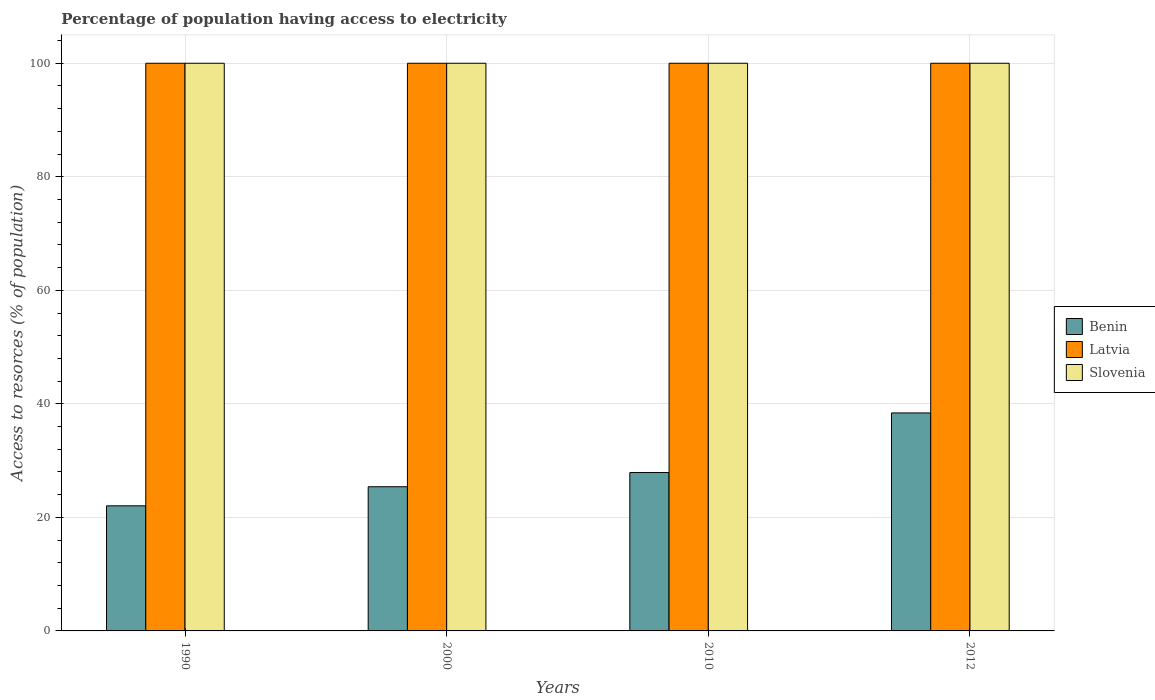Are the number of bars on each tick of the X-axis equal?
Provide a short and direct response. Yes. What is the percentage of population having access to electricity in Latvia in 1990?
Offer a terse response. 100. Across all years, what is the maximum percentage of population having access to electricity in Benin?
Your answer should be very brief. 38.4. Across all years, what is the minimum percentage of population having access to electricity in Slovenia?
Your answer should be compact. 100. In which year was the percentage of population having access to electricity in Latvia minimum?
Offer a terse response. 1990. What is the total percentage of population having access to electricity in Slovenia in the graph?
Give a very brief answer. 400. What is the difference between the percentage of population having access to electricity in Latvia in 2000 and that in 2012?
Provide a short and direct response. 0. What is the difference between the percentage of population having access to electricity in Slovenia in 2010 and the percentage of population having access to electricity in Benin in 1990?
Provide a succinct answer. 77.96. What is the average percentage of population having access to electricity in Benin per year?
Your answer should be very brief. 28.43. In the year 2012, what is the difference between the percentage of population having access to electricity in Latvia and percentage of population having access to electricity in Benin?
Give a very brief answer. 61.6. In how many years, is the percentage of population having access to electricity in Latvia greater than 28 %?
Your response must be concise. 4. What is the ratio of the percentage of population having access to electricity in Benin in 2010 to that in 2012?
Your response must be concise. 0.73. Is the difference between the percentage of population having access to electricity in Latvia in 2000 and 2012 greater than the difference between the percentage of population having access to electricity in Benin in 2000 and 2012?
Your answer should be compact. Yes. What is the difference between the highest and the second highest percentage of population having access to electricity in Benin?
Ensure brevity in your answer.  10.5. What is the difference between the highest and the lowest percentage of population having access to electricity in Benin?
Offer a very short reply. 16.36. What does the 3rd bar from the left in 2012 represents?
Make the answer very short. Slovenia. What does the 3rd bar from the right in 2012 represents?
Offer a terse response. Benin. Does the graph contain any zero values?
Provide a short and direct response. No. How many legend labels are there?
Make the answer very short. 3. How are the legend labels stacked?
Your answer should be very brief. Vertical. What is the title of the graph?
Offer a very short reply. Percentage of population having access to electricity. What is the label or title of the X-axis?
Ensure brevity in your answer.  Years. What is the label or title of the Y-axis?
Ensure brevity in your answer.  Access to resorces (% of population). What is the Access to resorces (% of population) in Benin in 1990?
Give a very brief answer. 22.04. What is the Access to resorces (% of population) of Latvia in 1990?
Give a very brief answer. 100. What is the Access to resorces (% of population) in Slovenia in 1990?
Your answer should be very brief. 100. What is the Access to resorces (% of population) in Benin in 2000?
Offer a very short reply. 25.4. What is the Access to resorces (% of population) in Benin in 2010?
Offer a very short reply. 27.9. What is the Access to resorces (% of population) in Slovenia in 2010?
Provide a succinct answer. 100. What is the Access to resorces (% of population) of Benin in 2012?
Provide a short and direct response. 38.4. What is the Access to resorces (% of population) of Slovenia in 2012?
Offer a terse response. 100. Across all years, what is the maximum Access to resorces (% of population) of Benin?
Offer a terse response. 38.4. Across all years, what is the maximum Access to resorces (% of population) of Latvia?
Offer a terse response. 100. Across all years, what is the maximum Access to resorces (% of population) of Slovenia?
Your response must be concise. 100. Across all years, what is the minimum Access to resorces (% of population) in Benin?
Ensure brevity in your answer.  22.04. Across all years, what is the minimum Access to resorces (% of population) of Latvia?
Ensure brevity in your answer.  100. What is the total Access to resorces (% of population) of Benin in the graph?
Provide a short and direct response. 113.74. What is the total Access to resorces (% of population) of Latvia in the graph?
Offer a very short reply. 400. What is the difference between the Access to resorces (% of population) of Benin in 1990 and that in 2000?
Keep it short and to the point. -3.36. What is the difference between the Access to resorces (% of population) of Latvia in 1990 and that in 2000?
Provide a succinct answer. 0. What is the difference between the Access to resorces (% of population) in Slovenia in 1990 and that in 2000?
Your response must be concise. 0. What is the difference between the Access to resorces (% of population) of Benin in 1990 and that in 2010?
Make the answer very short. -5.86. What is the difference between the Access to resorces (% of population) in Latvia in 1990 and that in 2010?
Keep it short and to the point. 0. What is the difference between the Access to resorces (% of population) in Benin in 1990 and that in 2012?
Your response must be concise. -16.36. What is the difference between the Access to resorces (% of population) in Slovenia in 1990 and that in 2012?
Offer a very short reply. 0. What is the difference between the Access to resorces (% of population) of Benin in 2000 and that in 2010?
Provide a succinct answer. -2.5. What is the difference between the Access to resorces (% of population) of Slovenia in 2000 and that in 2010?
Provide a short and direct response. 0. What is the difference between the Access to resorces (% of population) in Benin in 2000 and that in 2012?
Make the answer very short. -13. What is the difference between the Access to resorces (% of population) of Slovenia in 2000 and that in 2012?
Ensure brevity in your answer.  0. What is the difference between the Access to resorces (% of population) of Latvia in 2010 and that in 2012?
Make the answer very short. 0. What is the difference between the Access to resorces (% of population) of Slovenia in 2010 and that in 2012?
Your answer should be very brief. 0. What is the difference between the Access to resorces (% of population) in Benin in 1990 and the Access to resorces (% of population) in Latvia in 2000?
Your answer should be very brief. -77.96. What is the difference between the Access to resorces (% of population) in Benin in 1990 and the Access to resorces (% of population) in Slovenia in 2000?
Provide a succinct answer. -77.96. What is the difference between the Access to resorces (% of population) in Latvia in 1990 and the Access to resorces (% of population) in Slovenia in 2000?
Offer a terse response. 0. What is the difference between the Access to resorces (% of population) in Benin in 1990 and the Access to resorces (% of population) in Latvia in 2010?
Your answer should be compact. -77.96. What is the difference between the Access to resorces (% of population) of Benin in 1990 and the Access to resorces (% of population) of Slovenia in 2010?
Give a very brief answer. -77.96. What is the difference between the Access to resorces (% of population) of Latvia in 1990 and the Access to resorces (% of population) of Slovenia in 2010?
Provide a succinct answer. 0. What is the difference between the Access to resorces (% of population) in Benin in 1990 and the Access to resorces (% of population) in Latvia in 2012?
Your response must be concise. -77.96. What is the difference between the Access to resorces (% of population) of Benin in 1990 and the Access to resorces (% of population) of Slovenia in 2012?
Ensure brevity in your answer.  -77.96. What is the difference between the Access to resorces (% of population) in Latvia in 1990 and the Access to resorces (% of population) in Slovenia in 2012?
Give a very brief answer. 0. What is the difference between the Access to resorces (% of population) of Benin in 2000 and the Access to resorces (% of population) of Latvia in 2010?
Give a very brief answer. -74.6. What is the difference between the Access to resorces (% of population) of Benin in 2000 and the Access to resorces (% of population) of Slovenia in 2010?
Provide a succinct answer. -74.6. What is the difference between the Access to resorces (% of population) in Latvia in 2000 and the Access to resorces (% of population) in Slovenia in 2010?
Your response must be concise. 0. What is the difference between the Access to resorces (% of population) in Benin in 2000 and the Access to resorces (% of population) in Latvia in 2012?
Your answer should be compact. -74.6. What is the difference between the Access to resorces (% of population) in Benin in 2000 and the Access to resorces (% of population) in Slovenia in 2012?
Ensure brevity in your answer.  -74.6. What is the difference between the Access to resorces (% of population) in Latvia in 2000 and the Access to resorces (% of population) in Slovenia in 2012?
Provide a succinct answer. 0. What is the difference between the Access to resorces (% of population) of Benin in 2010 and the Access to resorces (% of population) of Latvia in 2012?
Your response must be concise. -72.1. What is the difference between the Access to resorces (% of population) in Benin in 2010 and the Access to resorces (% of population) in Slovenia in 2012?
Offer a very short reply. -72.1. What is the average Access to resorces (% of population) in Benin per year?
Keep it short and to the point. 28.43. In the year 1990, what is the difference between the Access to resorces (% of population) of Benin and Access to resorces (% of population) of Latvia?
Keep it short and to the point. -77.96. In the year 1990, what is the difference between the Access to resorces (% of population) in Benin and Access to resorces (% of population) in Slovenia?
Keep it short and to the point. -77.96. In the year 1990, what is the difference between the Access to resorces (% of population) in Latvia and Access to resorces (% of population) in Slovenia?
Make the answer very short. 0. In the year 2000, what is the difference between the Access to resorces (% of population) of Benin and Access to resorces (% of population) of Latvia?
Provide a short and direct response. -74.6. In the year 2000, what is the difference between the Access to resorces (% of population) in Benin and Access to resorces (% of population) in Slovenia?
Your response must be concise. -74.6. In the year 2010, what is the difference between the Access to resorces (% of population) of Benin and Access to resorces (% of population) of Latvia?
Provide a short and direct response. -72.1. In the year 2010, what is the difference between the Access to resorces (% of population) in Benin and Access to resorces (% of population) in Slovenia?
Your response must be concise. -72.1. In the year 2010, what is the difference between the Access to resorces (% of population) of Latvia and Access to resorces (% of population) of Slovenia?
Provide a short and direct response. 0. In the year 2012, what is the difference between the Access to resorces (% of population) in Benin and Access to resorces (% of population) in Latvia?
Ensure brevity in your answer.  -61.6. In the year 2012, what is the difference between the Access to resorces (% of population) of Benin and Access to resorces (% of population) of Slovenia?
Offer a terse response. -61.6. In the year 2012, what is the difference between the Access to resorces (% of population) of Latvia and Access to resorces (% of population) of Slovenia?
Your answer should be very brief. 0. What is the ratio of the Access to resorces (% of population) in Benin in 1990 to that in 2000?
Offer a terse response. 0.87. What is the ratio of the Access to resorces (% of population) of Benin in 1990 to that in 2010?
Your response must be concise. 0.79. What is the ratio of the Access to resorces (% of population) in Latvia in 1990 to that in 2010?
Offer a terse response. 1. What is the ratio of the Access to resorces (% of population) in Slovenia in 1990 to that in 2010?
Offer a very short reply. 1. What is the ratio of the Access to resorces (% of population) in Benin in 1990 to that in 2012?
Keep it short and to the point. 0.57. What is the ratio of the Access to resorces (% of population) in Benin in 2000 to that in 2010?
Your answer should be compact. 0.91. What is the ratio of the Access to resorces (% of population) of Benin in 2000 to that in 2012?
Make the answer very short. 0.66. What is the ratio of the Access to resorces (% of population) in Latvia in 2000 to that in 2012?
Ensure brevity in your answer.  1. What is the ratio of the Access to resorces (% of population) in Benin in 2010 to that in 2012?
Ensure brevity in your answer.  0.73. What is the ratio of the Access to resorces (% of population) in Latvia in 2010 to that in 2012?
Your answer should be compact. 1. What is the ratio of the Access to resorces (% of population) of Slovenia in 2010 to that in 2012?
Ensure brevity in your answer.  1. What is the difference between the highest and the second highest Access to resorces (% of population) of Latvia?
Offer a terse response. 0. What is the difference between the highest and the lowest Access to resorces (% of population) of Benin?
Your answer should be very brief. 16.36. What is the difference between the highest and the lowest Access to resorces (% of population) in Slovenia?
Provide a succinct answer. 0. 